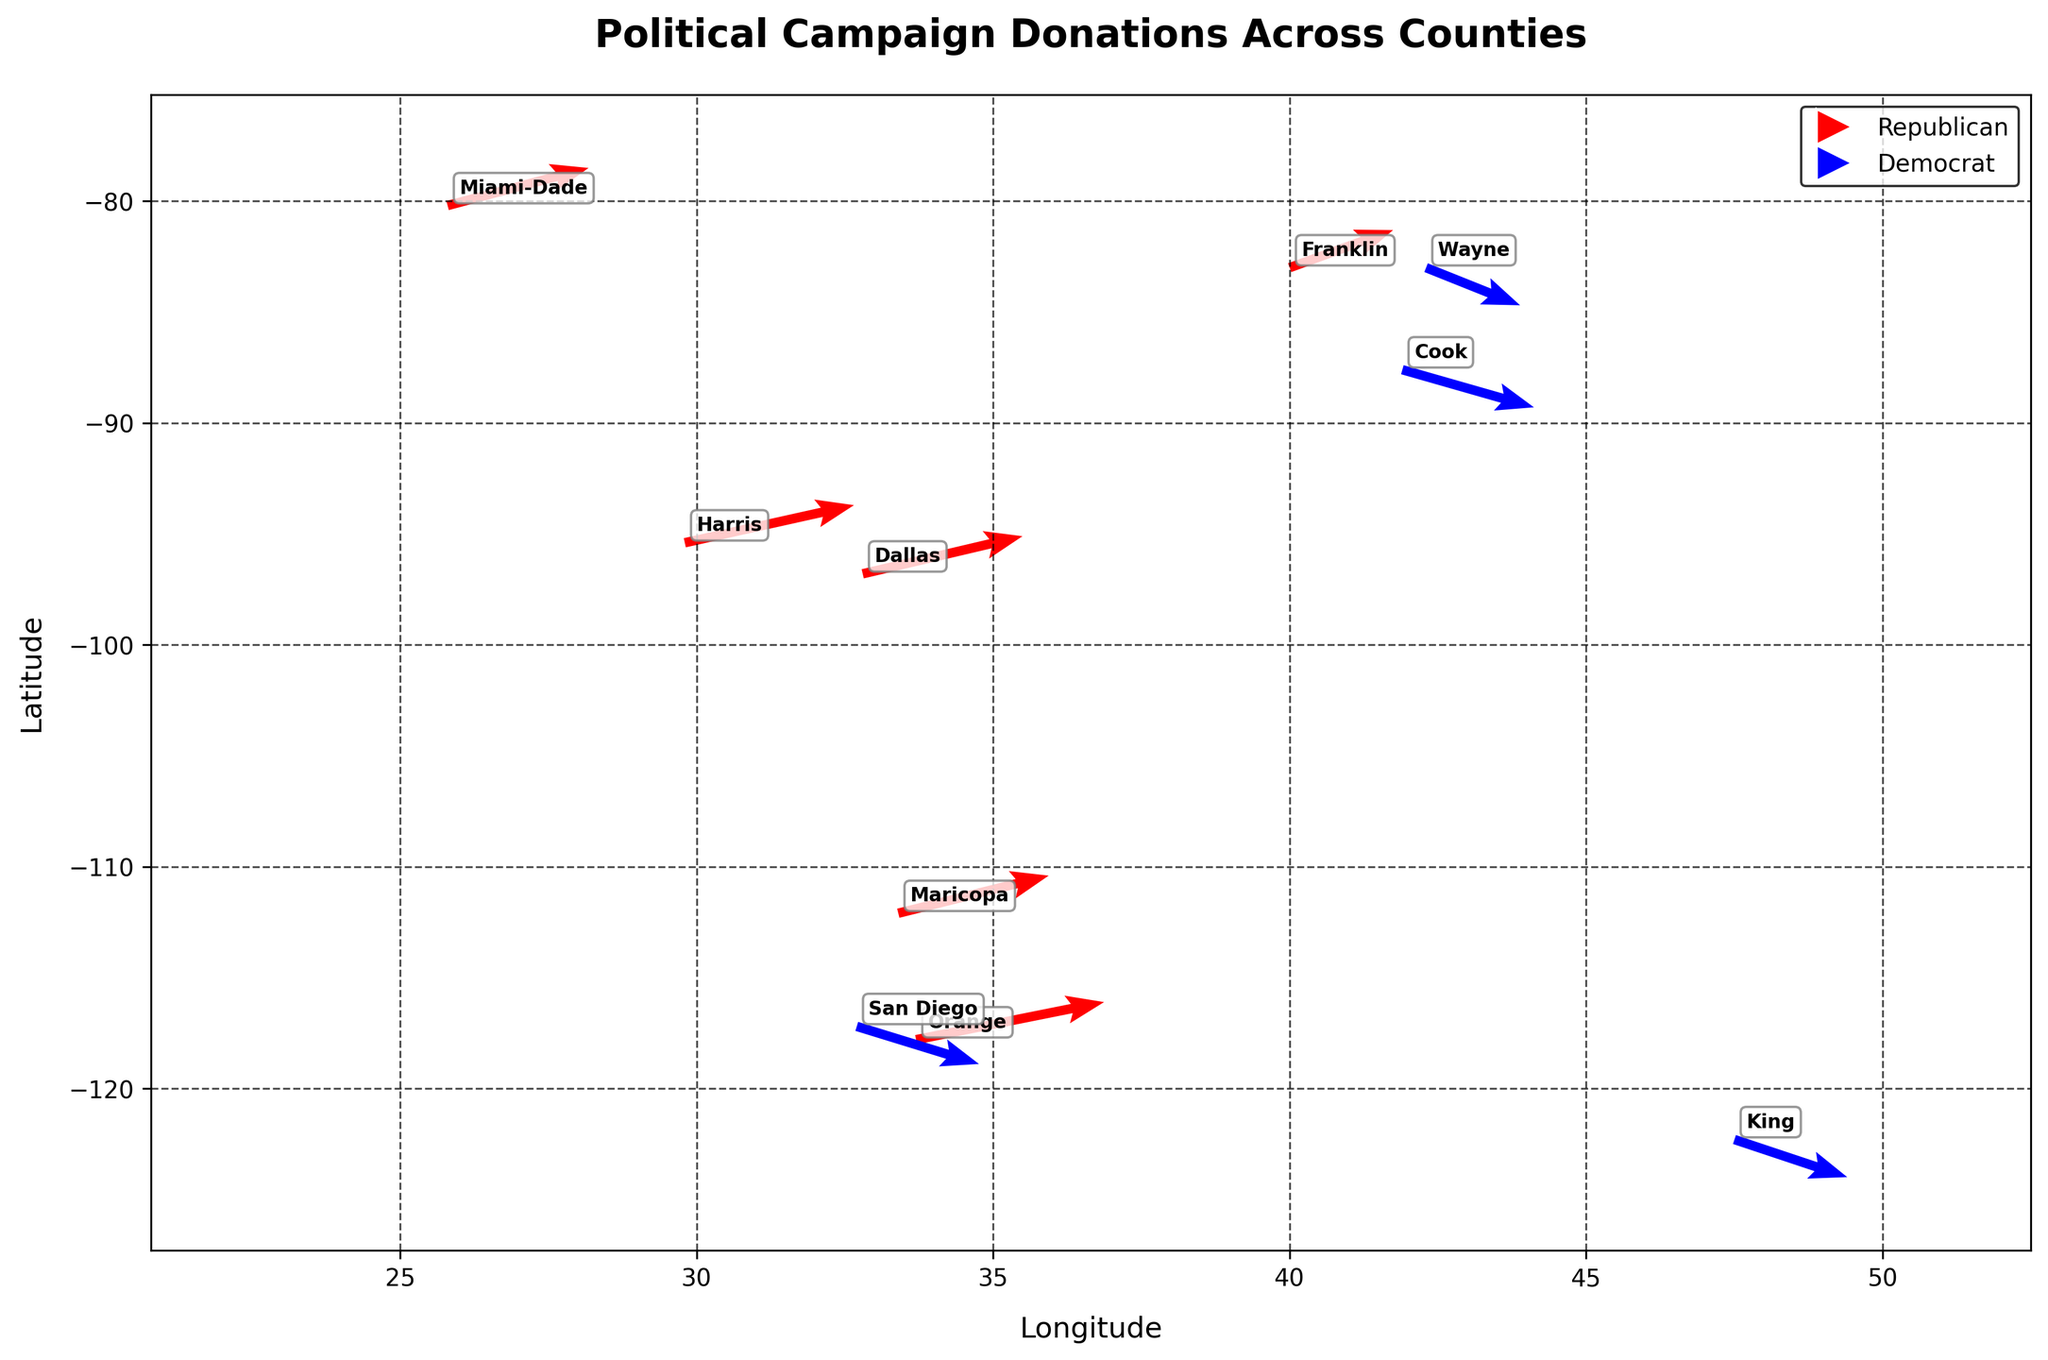How many counties have data points in the plot? The plot shows arrows for 10 different counties, each represented by a unique arrow.
Answer: 10 Which party has the longest arrow on the quiver plot? The length of the arrow is proportional to the donation amount. The longest arrow points upward, indicating a Republican county. Orange County has the longest arrow with a $500,000 donation.
Answer: Republican What is the donation amount in Harris County? By looking at the quiver plot, each arrow length is proportional to the donation amount divided by 100,000. Harris's arrow length is 4.5 units, indicating a $450,000 donation.
Answer: $450,000 How many counties donated more than $400,000? We need to check arrows longer than 4 units. Four arrows meet this criterion: Orange with 5 units, Harris with 4.5, Dallas with 4.25, and Maricopa with 4 units.
Answer: 4 Which county is identified by a blue arrow and has a lower donation amount between King and Wayne? Blue arrows represent Democrat counties. Comparing King (with a 3-unit arrow) and Wayne (with a 2.5-unit arrow), Wayne has the lower donation amount.
Answer: Wayne Which county's donation vector is pointing downward and contains more than $300,000? Downward arrows belong to Democrat areas. King County, identified by the largest downward blue arrow (3 units), donated $300,000.
Answer: King Do more counties in the plot support the Republican or the Democrat party? By color-coding, there are more red arrows (Republican) than blue arrows (Democrat). Specifically, 6 are Republican and 4 are Democrat.
Answer: Republican Which counties' arrows have the exact same direction? Check counties with arrows pointing straight up or down. Harris, Orange, Miami-Dade, Franklin, Maricopa, and Dallas all point upwards (Republican). King, Cook, San Diego, and Wayne point downward (Democrat).
Answer: Harris, Orange, Miami-Dade, Franklin, Maricopa, Dallas (upwards); King, Cook, San Diego, Wayne (downwards) What is the sum total donation amount from all Republican counties? Summing the Republican donations: Orange ($500,000), Harris ($450,000), Maricopa ($400,000), Miami-Dade ($375,000), Dallas ($425,000), Franklin ($275,000). The total is $2,425,000.
Answer: $2,425,000 